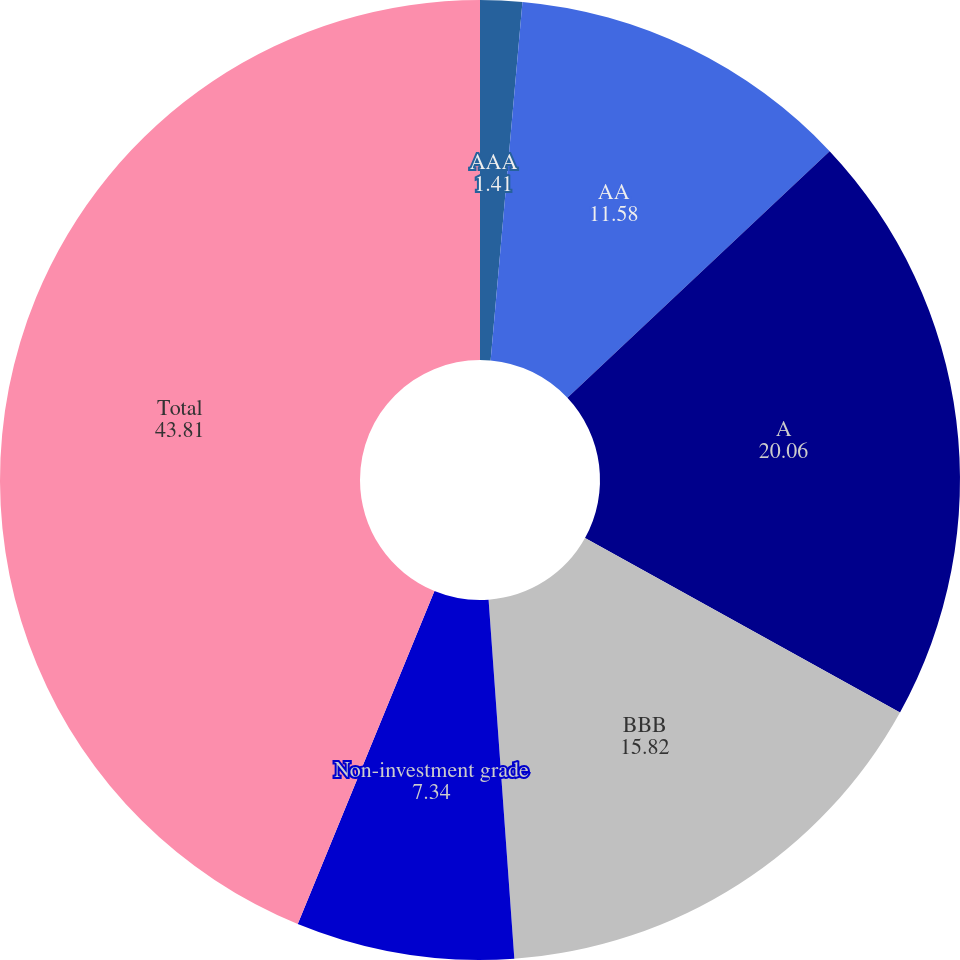Convert chart. <chart><loc_0><loc_0><loc_500><loc_500><pie_chart><fcel>AAA<fcel>AA<fcel>A<fcel>BBB<fcel>Non-investment grade<fcel>Total<nl><fcel>1.41%<fcel>11.58%<fcel>20.06%<fcel>15.82%<fcel>7.34%<fcel>43.81%<nl></chart> 